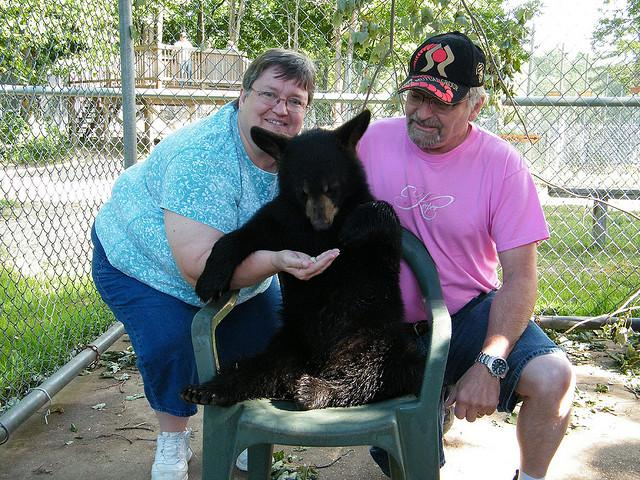What is the woman doing with the bear?

Choices:
A) cleaning it
B) feeding it
C) smothering it
D) fighting it feeding it 